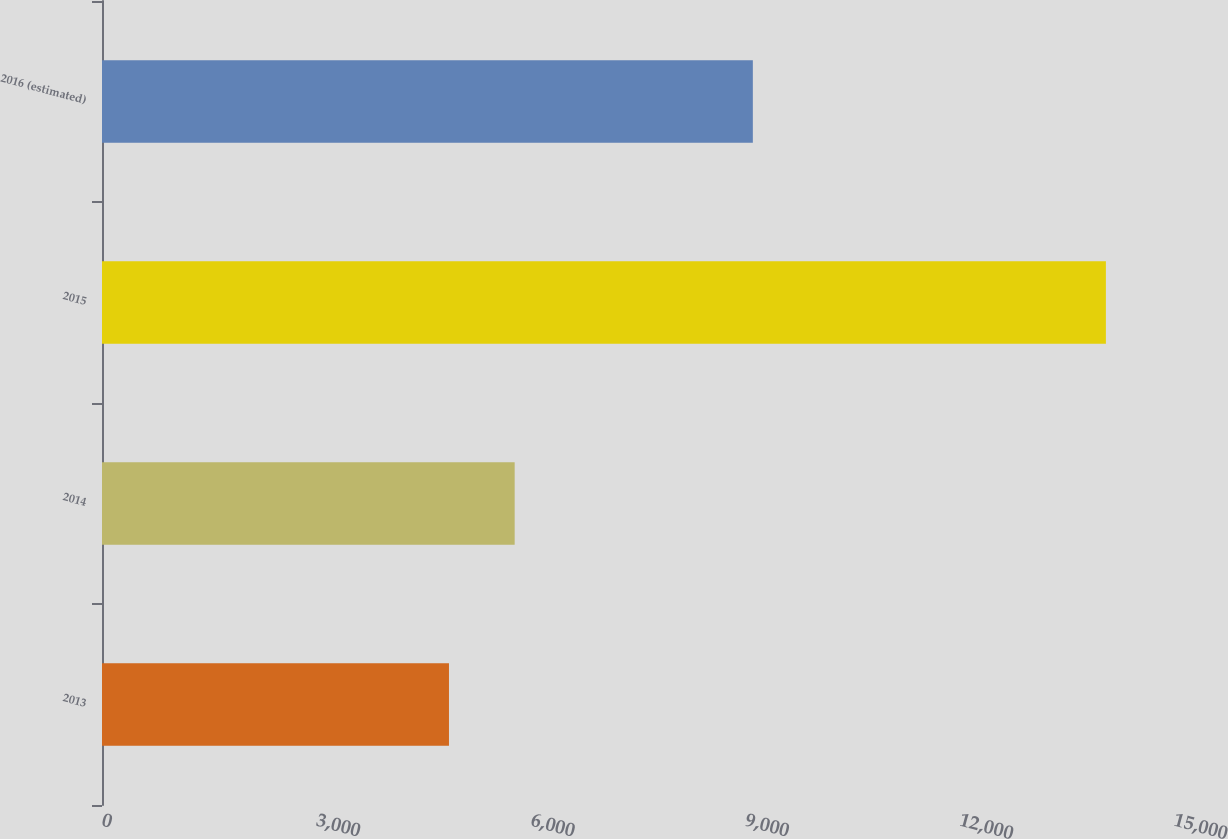Convert chart. <chart><loc_0><loc_0><loc_500><loc_500><bar_chart><fcel>2013<fcel>2014<fcel>2015<fcel>2016 (estimated)<nl><fcel>4855<fcel>5774.2<fcel>14047<fcel>9107<nl></chart> 